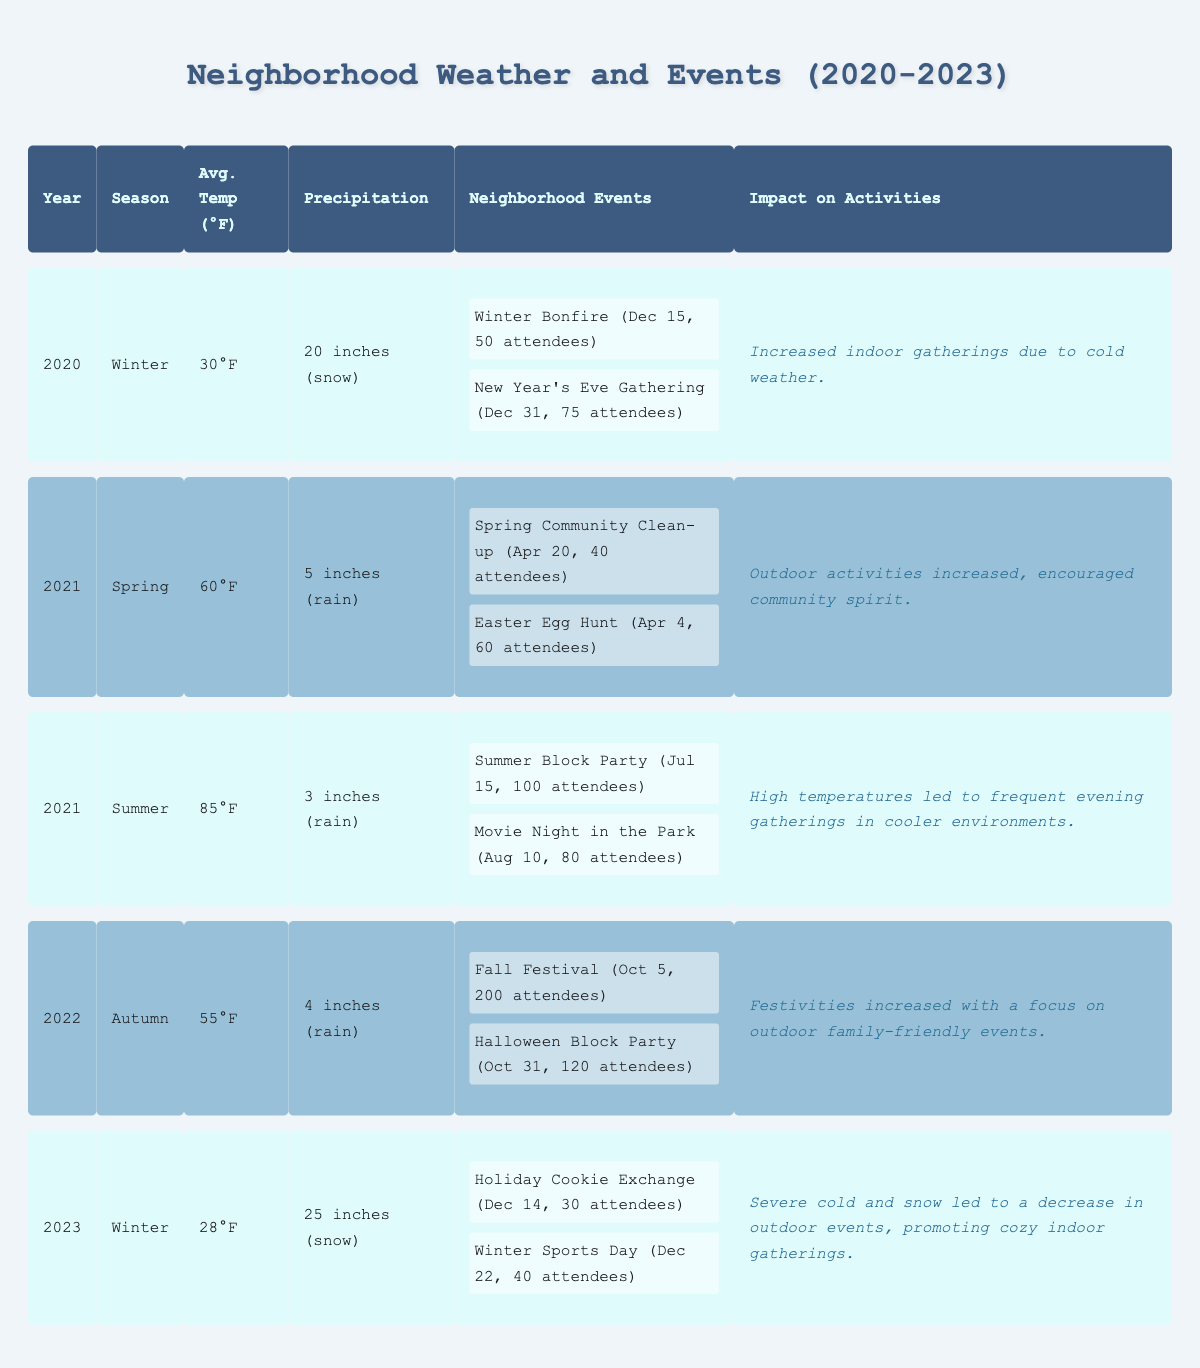What was the average temperature during Spring 2021? According to the table, the average temperature for Spring 2021 is listed as 60°F.
Answer: 60°F How many attendees were at the Fall Festival in 2022? The Fall Festival in 2022 had an attendance of 200 people, as noted in the neighborhood events section for that year.
Answer: 200 What was the precipitation during Winter 2023? The precipitation for Winter 2023 is reported as 25 inches of snow in the table.
Answer: 25 inches Did the Summer 2021 have more events than Winter 2020? Winter 2020 had 2 events (Winter Bonfire and New Year’s Eve Gathering), while Summer 2021 also had 2 events (Summer Block Party and Movie Night). Therefore, it is False that Summer 2021 had more events than Winter 2020.
Answer: No Which season in 2022 had the highest attendance for neighborhood events? In 2022, the Autumn season had the highest attendance with the Fall Festival (200 attendees) and Halloween Block Party (120 attendees), totaling 320 attendees. No other seasons in 2022 had as many people at their events.
Answer: Autumn What was the temperature difference between Winter 2020 and Winter 2023? Winter 2020 had an average temperature of 30°F, while Winter 2023 had an average temperature of 28°F. The difference is calculated by subtracting 28 from 30, resulting in a difference of 2°F.
Answer: 2°F During which season was “Spring Community Clean-up” held, and what was its attendance? The “Spring Community Clean-up” event was held in Spring 2021, and it had an attendance of 40 people, as shown in the events list for that season.
Answer: Spring 2021, 40 attendees In which season did neighborhood events lead to a significant increase in outdoor activities? The Spring of 2021 is noted for increased outdoor activities and community spirit, as indicated in the impact on activities section for that season.
Answer: Spring 2021 Was the impact on activities for Winter 2023 more focused on outdoor gatherings or indoor gatherings? The impact on activities for Winter 2023 states that severe cold and snow led to a decrease in outdoor events and an increase in cozy indoor gatherings. Therefore, it was more focused on indoor gatherings.
Answer: Indoor gatherings Which year had the lowest average temperature? According to the table, Winter 2023 had the lowest average temperature of 28°F. This is the lowest when compared to the other seasons listed.
Answer: 2023 